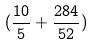<formula> <loc_0><loc_0><loc_500><loc_500>( \frac { 1 0 } { 5 } + \frac { 2 8 4 } { 5 2 } )</formula> 